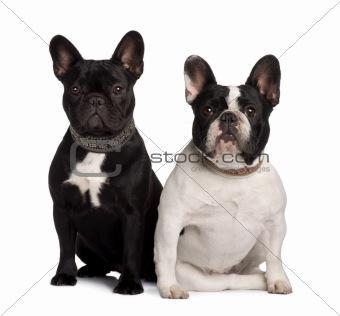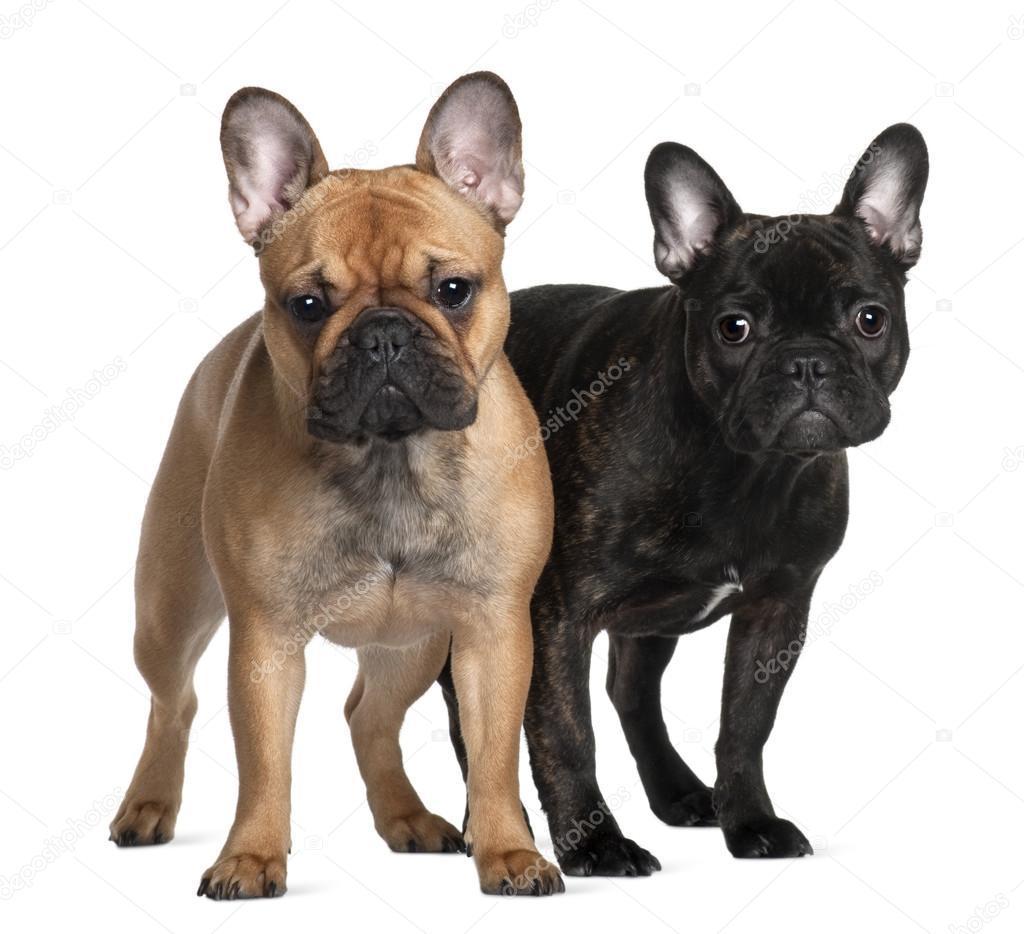The first image is the image on the left, the second image is the image on the right. Examine the images to the left and right. Is the description "Two dogs are standing up in one of the images." accurate? Answer yes or no. Yes. The first image is the image on the left, the second image is the image on the right. For the images displayed, is the sentence "Each image contains two big-eared dogs, and one pair of dogs includes a mostly black one and a mostly white one." factually correct? Answer yes or no. Yes. 